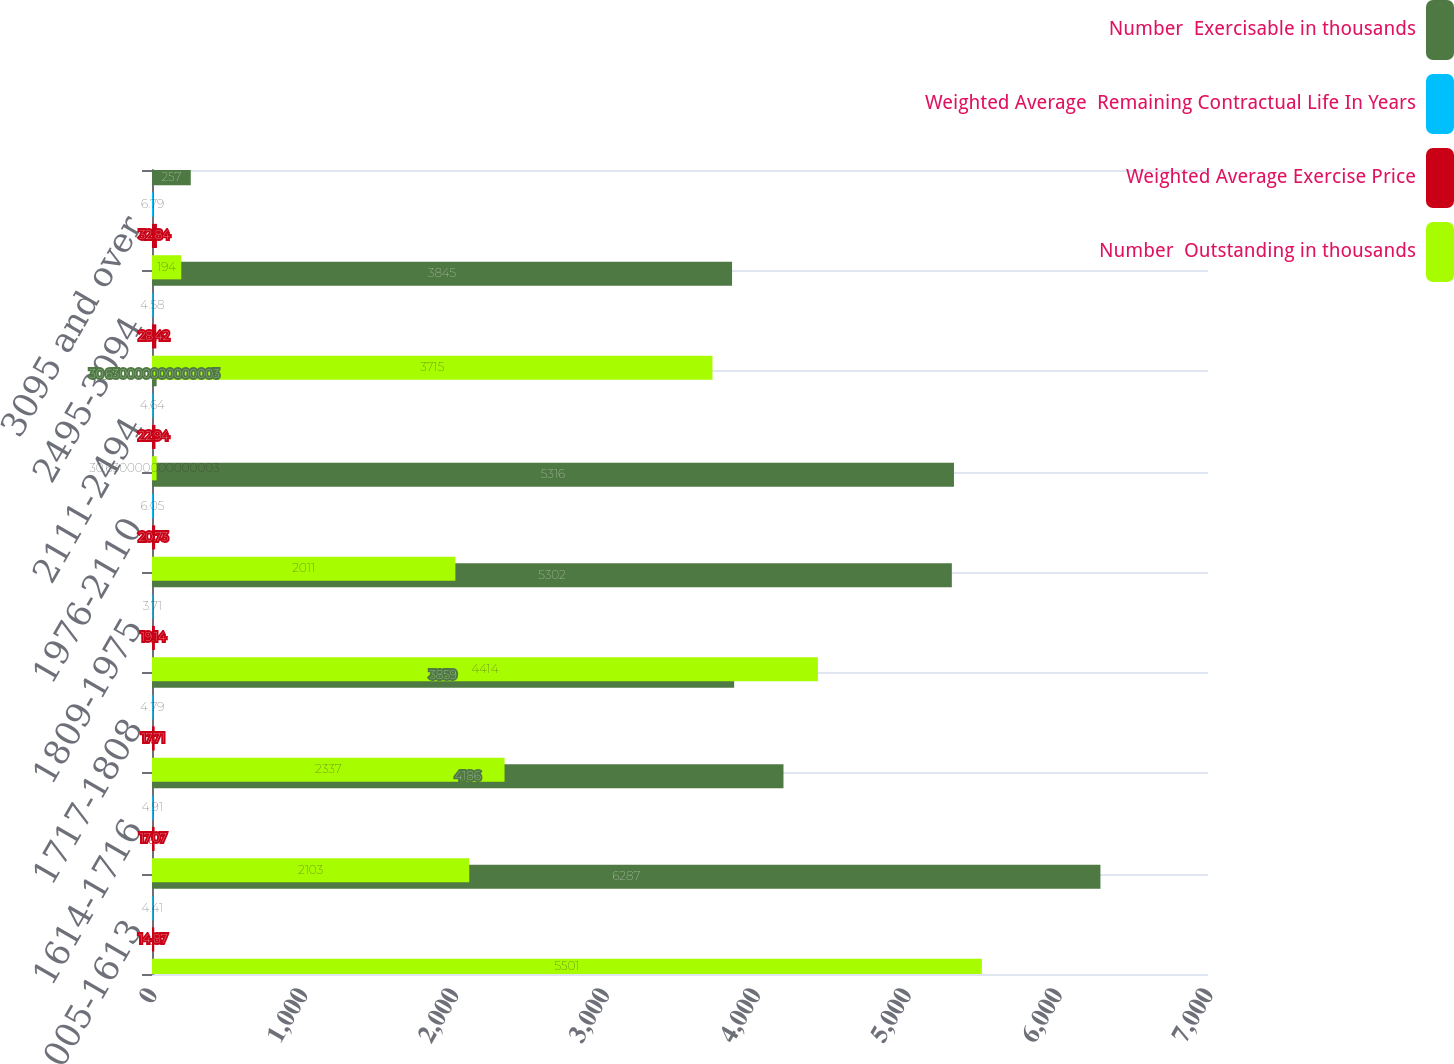Convert chart to OTSL. <chart><loc_0><loc_0><loc_500><loc_500><stacked_bar_chart><ecel><fcel>005-1613<fcel>1614-1716<fcel>1717-1808<fcel>1809-1975<fcel>1976-2110<fcel>2111-2494<fcel>2495-3094<fcel>3095 and over<nl><fcel>Number  Exercisable in thousands<fcel>6287<fcel>4186<fcel>3859<fcel>5302<fcel>5316<fcel>30.63<fcel>3845<fcel>257<nl><fcel>Weighted Average  Remaining Contractual Life In Years<fcel>4.41<fcel>4.91<fcel>4.79<fcel>3.71<fcel>6.05<fcel>4.64<fcel>4.58<fcel>6.79<nl><fcel>Weighted Average Exercise Price<fcel>14.87<fcel>17.07<fcel>17.71<fcel>19.14<fcel>20.73<fcel>22.94<fcel>28.42<fcel>32.84<nl><fcel>Number  Outstanding in thousands<fcel>5501<fcel>2103<fcel>2337<fcel>4414<fcel>2011<fcel>30.63<fcel>3715<fcel>194<nl></chart> 